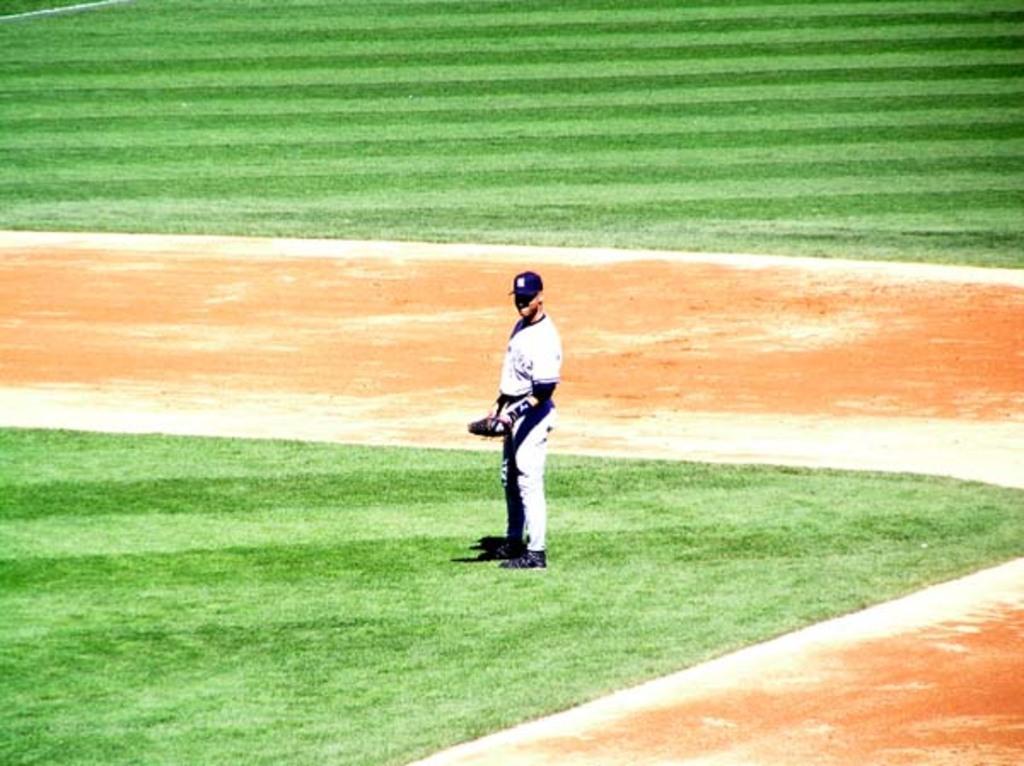Please provide a concise description of this image. This picture is clicked outside. In the center there is a person holding some object and standing on the ground, we can see the green grass on the ground. 